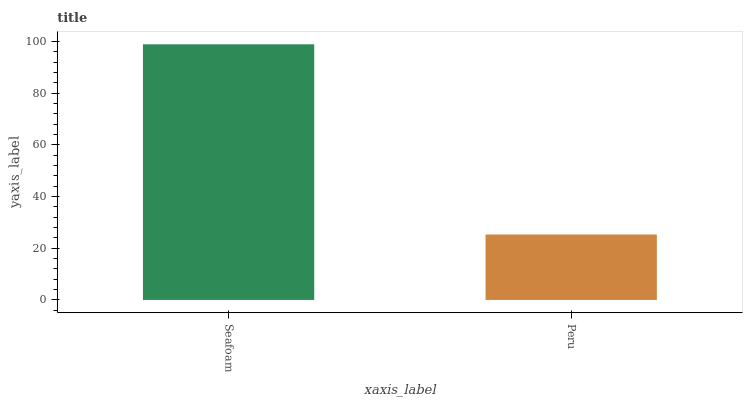Is Peru the minimum?
Answer yes or no. Yes. Is Seafoam the maximum?
Answer yes or no. Yes. Is Peru the maximum?
Answer yes or no. No. Is Seafoam greater than Peru?
Answer yes or no. Yes. Is Peru less than Seafoam?
Answer yes or no. Yes. Is Peru greater than Seafoam?
Answer yes or no. No. Is Seafoam less than Peru?
Answer yes or no. No. Is Seafoam the high median?
Answer yes or no. Yes. Is Peru the low median?
Answer yes or no. Yes. Is Peru the high median?
Answer yes or no. No. Is Seafoam the low median?
Answer yes or no. No. 